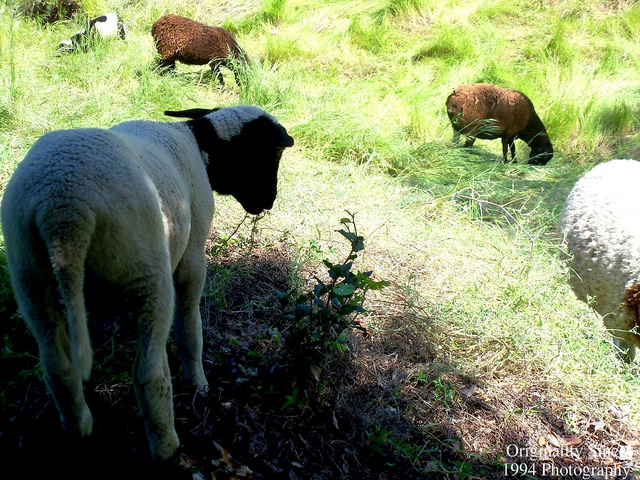Please extract the text content from this image. Originality 1994 Photography 